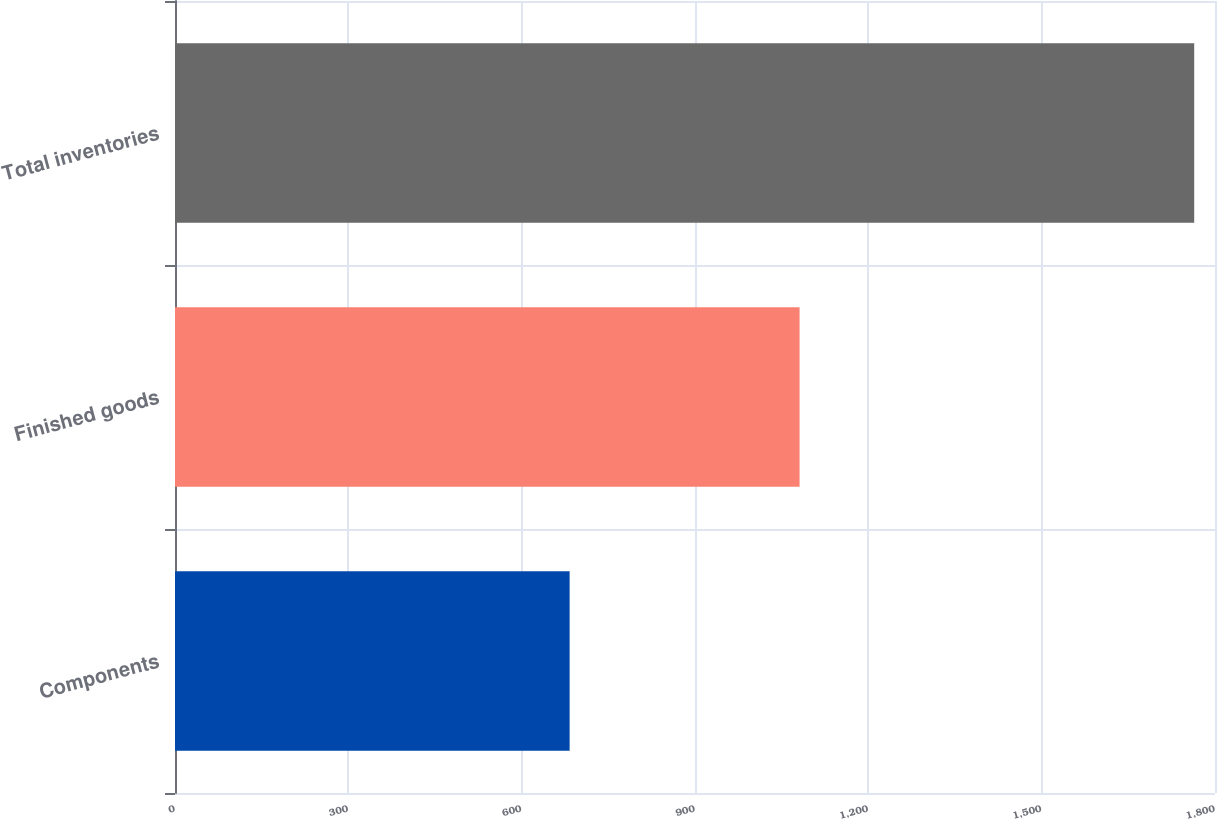<chart> <loc_0><loc_0><loc_500><loc_500><bar_chart><fcel>Components<fcel>Finished goods<fcel>Total inventories<nl><fcel>683<fcel>1081<fcel>1764<nl></chart> 